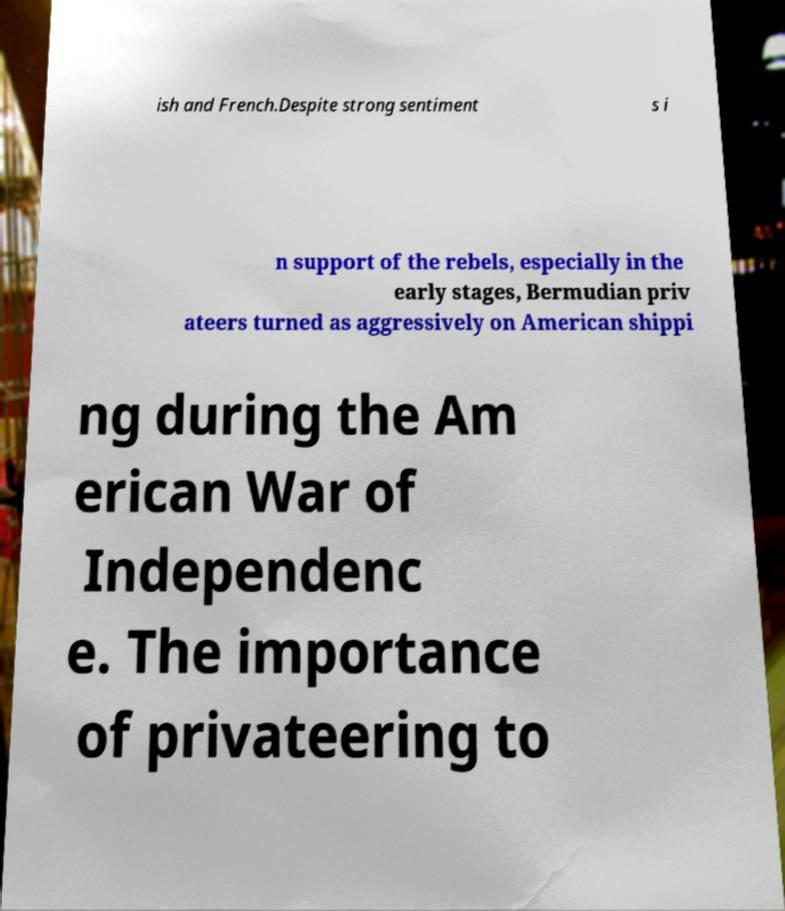What messages or text are displayed in this image? I need them in a readable, typed format. ish and French.Despite strong sentiment s i n support of the rebels, especially in the early stages, Bermudian priv ateers turned as aggressively on American shippi ng during the Am erican War of Independenc e. The importance of privateering to 